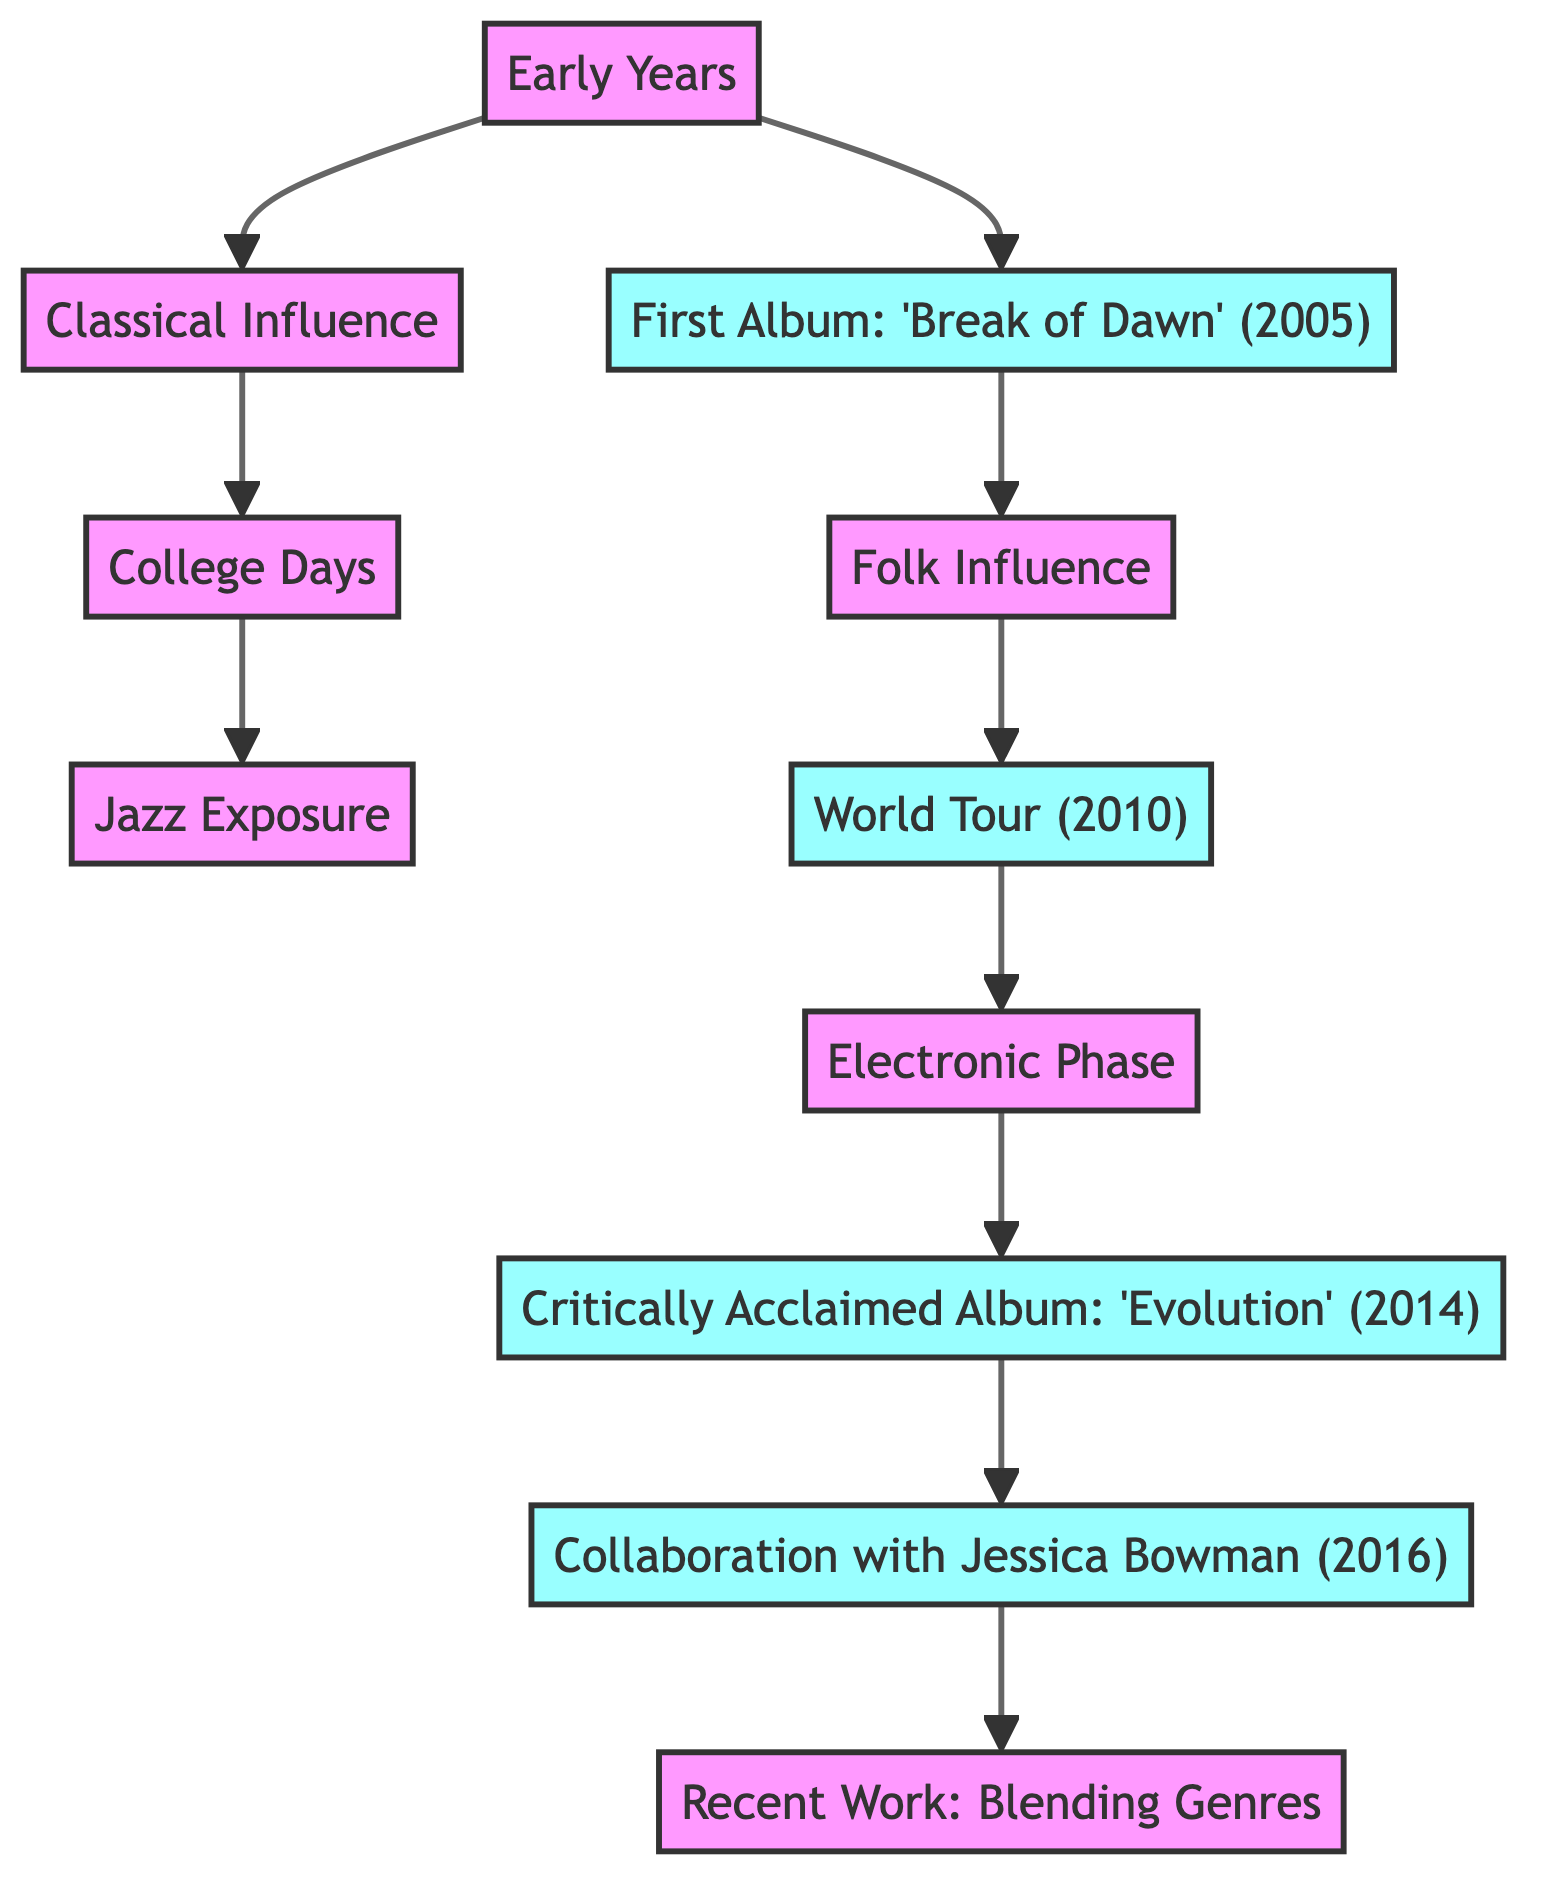What was the name of Brent Moffitt's first album? The diagram clearly states that his first album is titled "Break of Dawn." The node labeled "First Album" contains this title.
Answer: Break of Dawn In what year was 'Evolution' released? The node labeled "Critically Acclaimed Album" indicates that 'Evolution' was released in 2014.
Answer: 2014 Which milestone is linked to both world tour and electronic phase? Following the flow, the "World Tour" node connects to the "Electronic Phase" node, indicating the transition influenced by the tour.
Answer: Electronic Phase How many edges are in the diagram? To find the number of edges, count the connections between nodes. There are 9 edges in total as listed in the edges section of the data.
Answer: 9 What new influence did Brent Moffitt incorporate after his first album? The node "Folk Influence" directly follows "First Album," indicating that he started incorporating folk elements after that.
Answer: Folk Influence What is a key aspect of Brent Moffitt's recent work? The node "Recent Work" states that it focuses on blending genres, indicating the current direction of his music.
Answer: Blending Genres What phase occurred right after the world tour in 2010? The diagram indicates that the "Electronic Phase" follows "World Tour," establishing the order of events.
Answer: Electronic Phase What two styles influenced Brent during his college days? The flow shows connections from "College Days" to "Jazz Exposure" and "Classical Influence," indicating both styles influenced him during that time.
Answer: Jazz and Classical Which node represents Brent Moffitt's collaboration in 2016? The diagram identifies "Collaboration with Jessica Bowman" as the specific node indicating the collaborative work that took place in 2016.
Answer: Collaboration with Jessica Bowman 